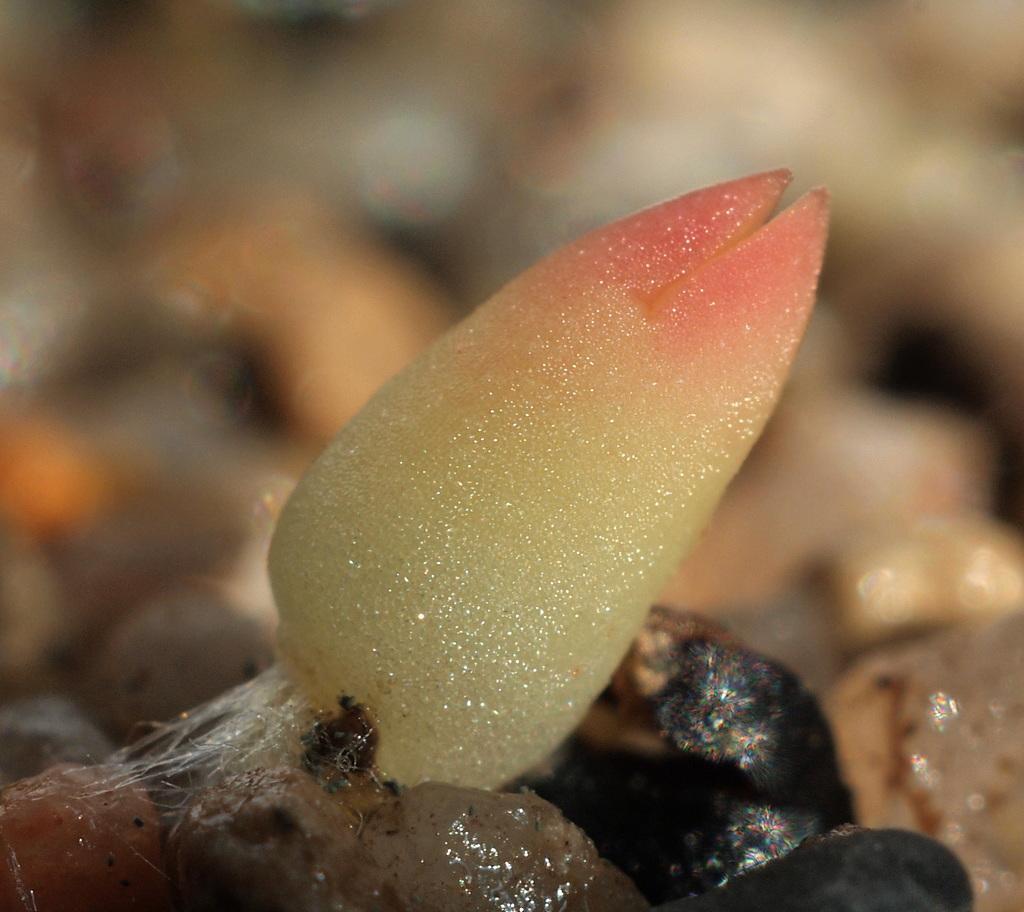Could you give a brief overview of what you see in this image? This is a zoomed in picture. In the foreground we can see a marine object and the background of the image is blurry. 